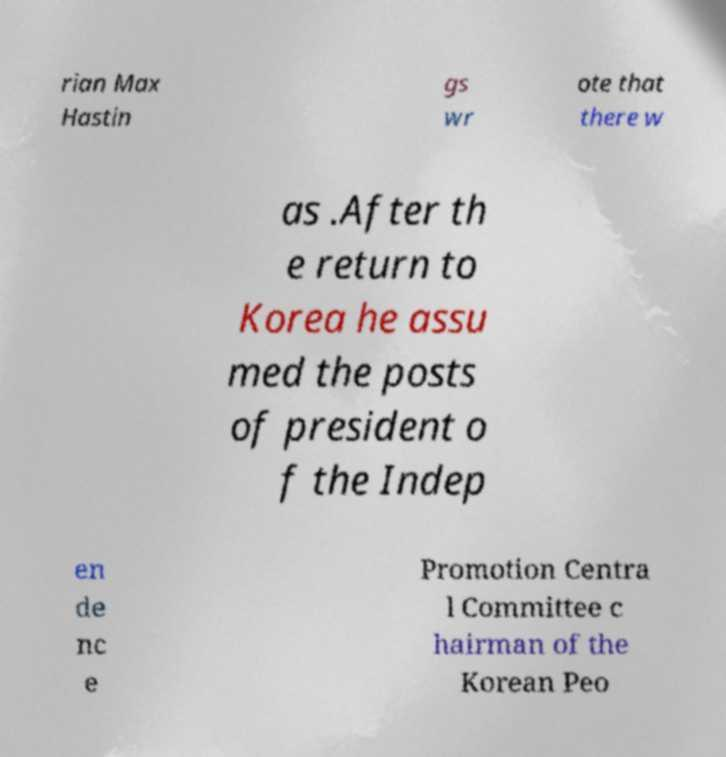I need the written content from this picture converted into text. Can you do that? rian Max Hastin gs wr ote that there w as .After th e return to Korea he assu med the posts of president o f the Indep en de nc e Promotion Centra l Committee c hairman of the Korean Peo 